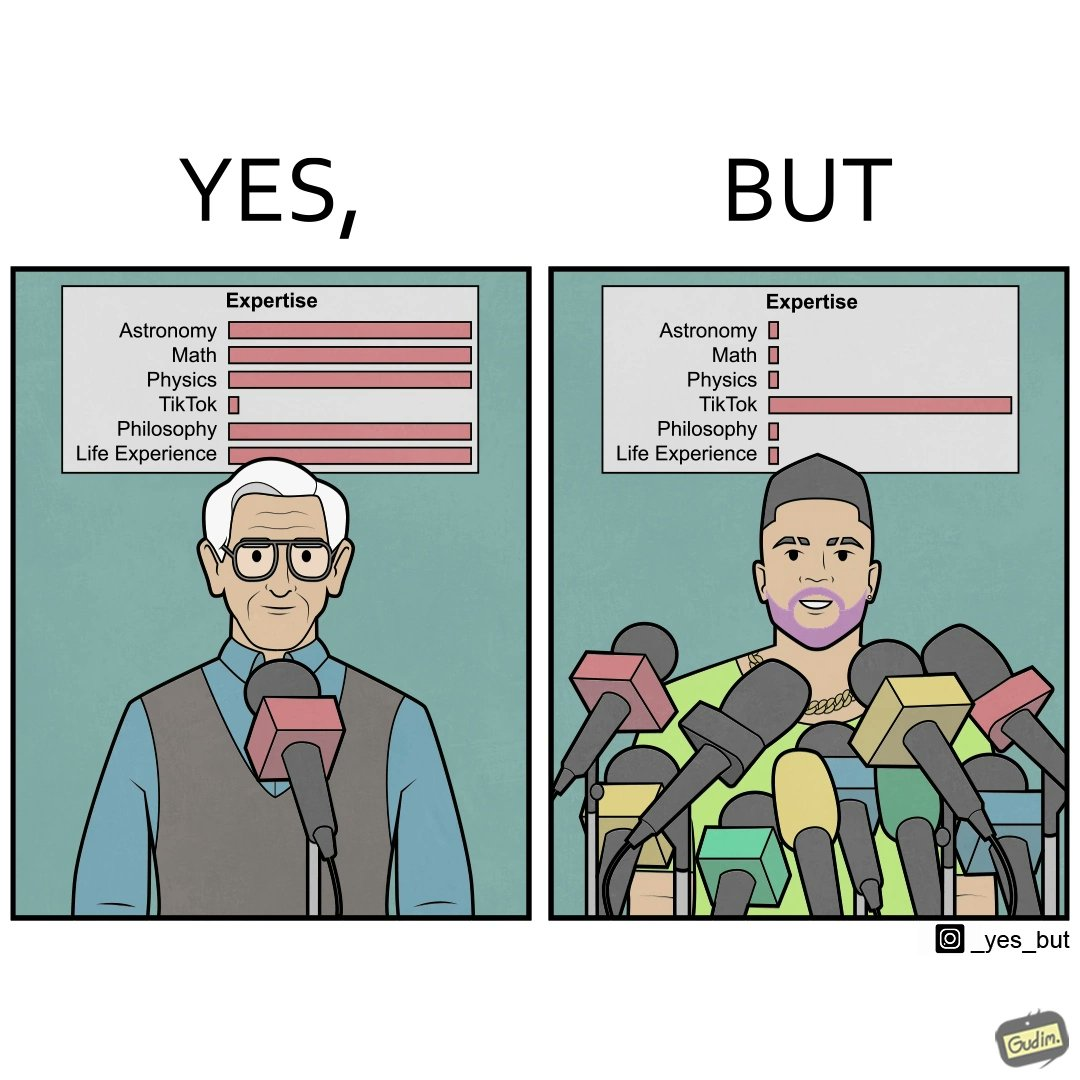Compare the left and right sides of this image. In the left part of the image: The image shows an old man speaking into a microphone. The image also shows the man's expertise in several areas such as Astronomy, Math, Physics, TikTok, Philosophy and Life Experience. The man has 100% exepertise in all the areas except Tik Tok where he has less than 5% exepertise. In the right part of the image: The image shows a you man speaking into several microphones. The image also shows the man's expertise in several areas such as Astronomy, Math, Physics, TikTok, Philosophy and Life Experience. The man has  less than 5% exepertise in all the areas except Tik Tok where he has 100% expertise. 